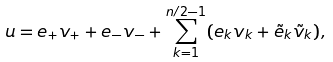Convert formula to latex. <formula><loc_0><loc_0><loc_500><loc_500>u = e _ { + } v _ { + } + e _ { - } v _ { - } + \sum _ { k = 1 } ^ { n / 2 - 1 } ( e _ { k } v _ { k } + \tilde { e } _ { k } \tilde { v } _ { k } ) ,</formula> 